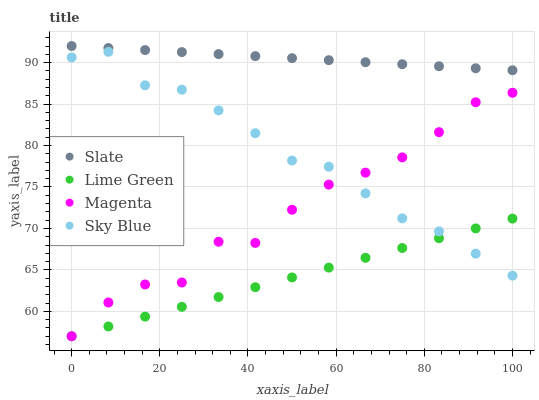Does Lime Green have the minimum area under the curve?
Answer yes or no. Yes. Does Slate have the maximum area under the curve?
Answer yes or no. Yes. Does Slate have the minimum area under the curve?
Answer yes or no. No. Does Lime Green have the maximum area under the curve?
Answer yes or no. No. Is Slate the smoothest?
Answer yes or no. Yes. Is Magenta the roughest?
Answer yes or no. Yes. Is Lime Green the smoothest?
Answer yes or no. No. Is Lime Green the roughest?
Answer yes or no. No. Does Lime Green have the lowest value?
Answer yes or no. Yes. Does Slate have the lowest value?
Answer yes or no. No. Does Slate have the highest value?
Answer yes or no. Yes. Does Lime Green have the highest value?
Answer yes or no. No. Is Sky Blue less than Slate?
Answer yes or no. Yes. Is Slate greater than Magenta?
Answer yes or no. Yes. Does Sky Blue intersect Magenta?
Answer yes or no. Yes. Is Sky Blue less than Magenta?
Answer yes or no. No. Is Sky Blue greater than Magenta?
Answer yes or no. No. Does Sky Blue intersect Slate?
Answer yes or no. No. 